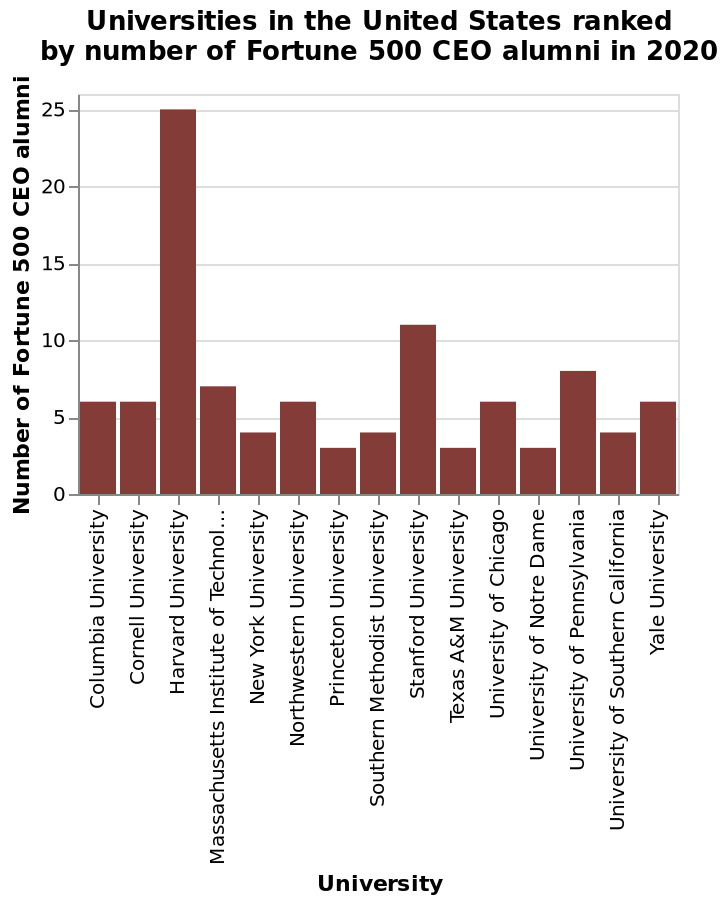<image>
What is the difference in the number of fortune 500 CEO alumni between Prince and Harvard? The difference in the number of fortune 500 CEO alumni between Prince and Harvard is approximately 22.6. What university has the highest number of fortune 500 CEO alumni? Harvard has the highest number of fortune 500 CEO alumni by an exceptional margin, at 25 alumni. please enumerates aspects of the construction of the chart This bar chart is named Universities in the United States ranked by number of Fortune 500 CEO alumni in 2020. There is a linear scale with a minimum of 0 and a maximum of 25 on the y-axis, marked Number of Fortune 500 CEO alumni. The x-axis shows University as a categorical scale starting with Columbia University and ending with Yale University. What is the scale used on the y-axis?  The scale used on the y-axis is a linear scale. 